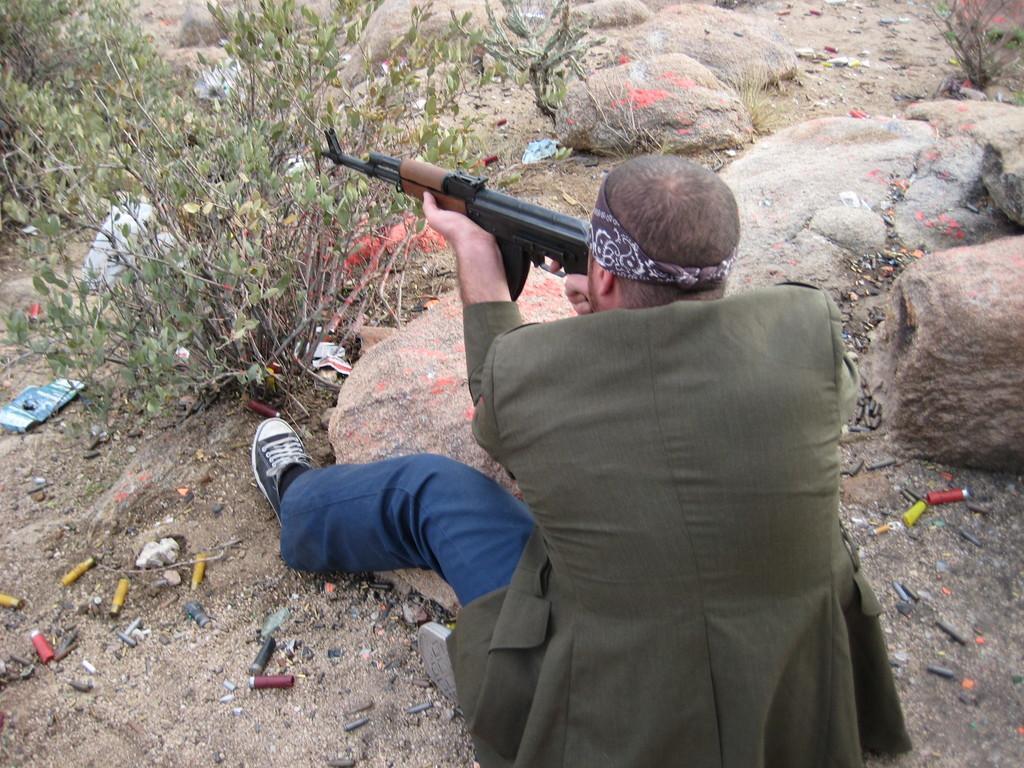Could you give a brief overview of what you see in this image? In this image there is a person sitting on the surface and he is holding a gun, in front of him there are a few plants and rocks, there are a few objects on the surface. 